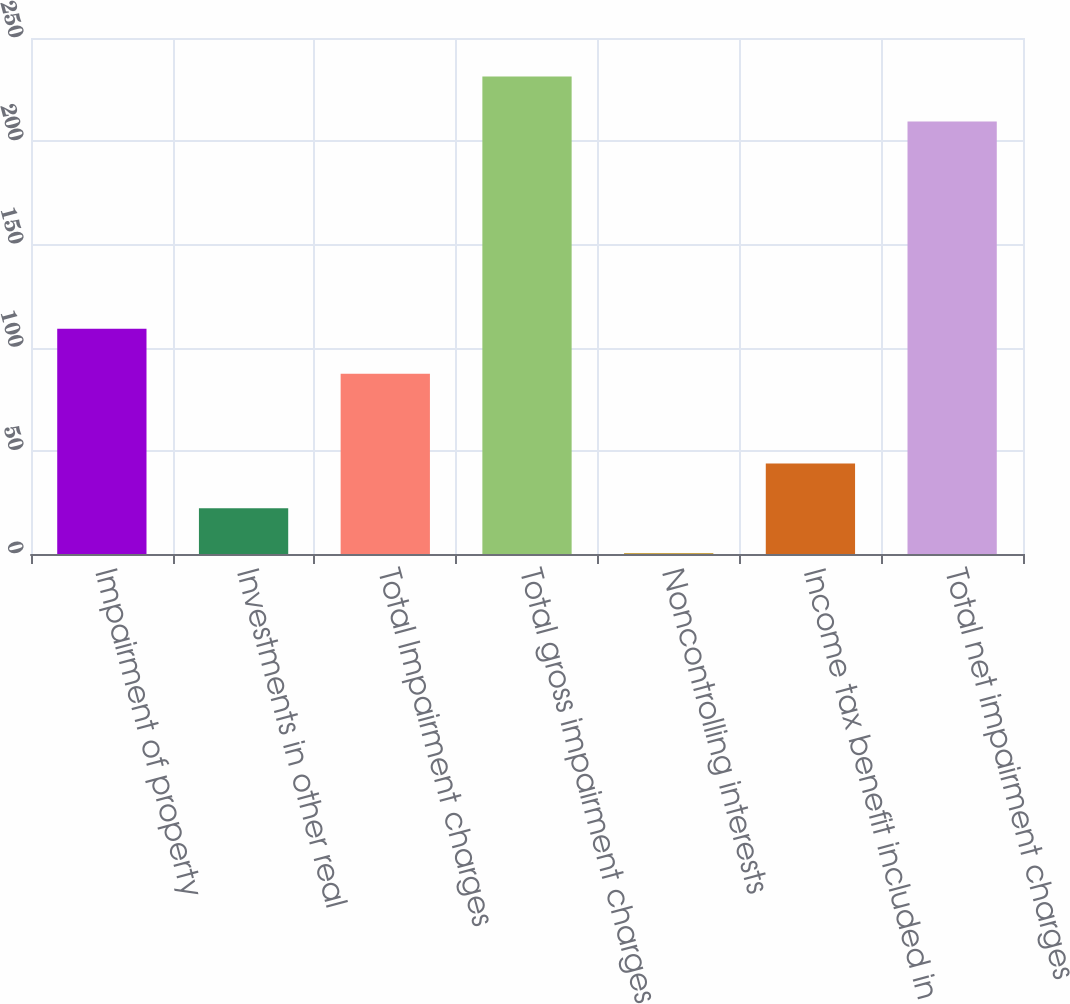Convert chart to OTSL. <chart><loc_0><loc_0><loc_500><loc_500><bar_chart><fcel>Impairment of property<fcel>Investments in other real<fcel>Total Impairment charges<fcel>Total gross impairment charges<fcel>Noncontrolling interests<fcel>Income tax benefit included in<fcel>Total net impairment charges<nl><fcel>109.1<fcel>22.14<fcel>87.36<fcel>231.34<fcel>0.4<fcel>43.88<fcel>209.6<nl></chart> 